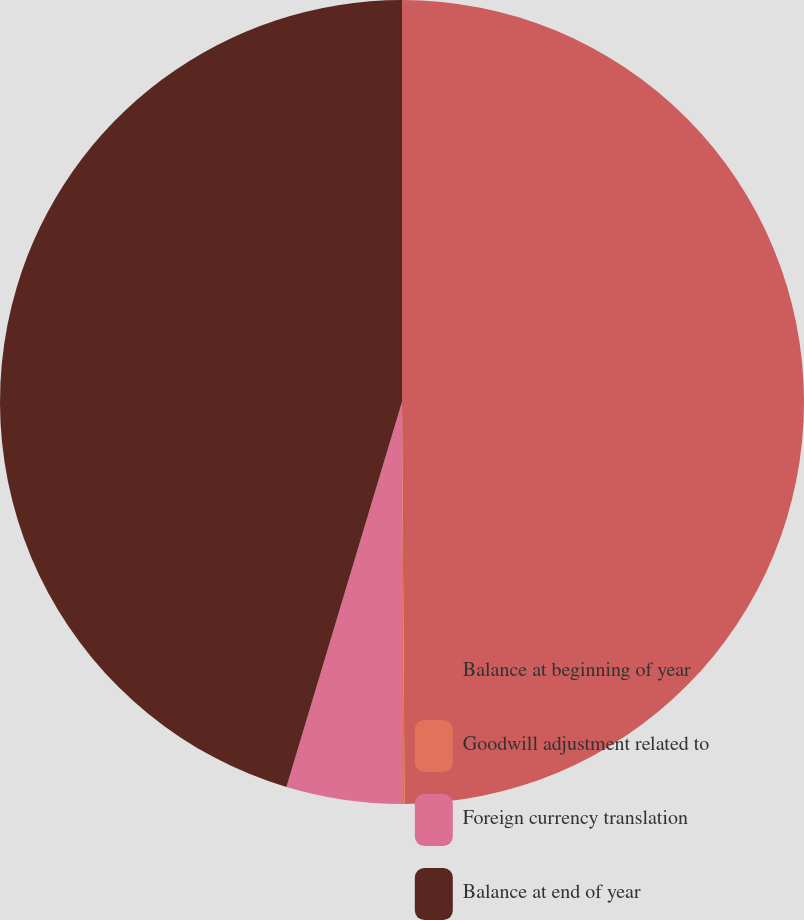<chart> <loc_0><loc_0><loc_500><loc_500><pie_chart><fcel>Balance at beginning of year<fcel>Goodwill adjustment related to<fcel>Foreign currency translation<fcel>Balance at end of year<nl><fcel>49.9%<fcel>0.1%<fcel>4.64%<fcel>45.36%<nl></chart> 